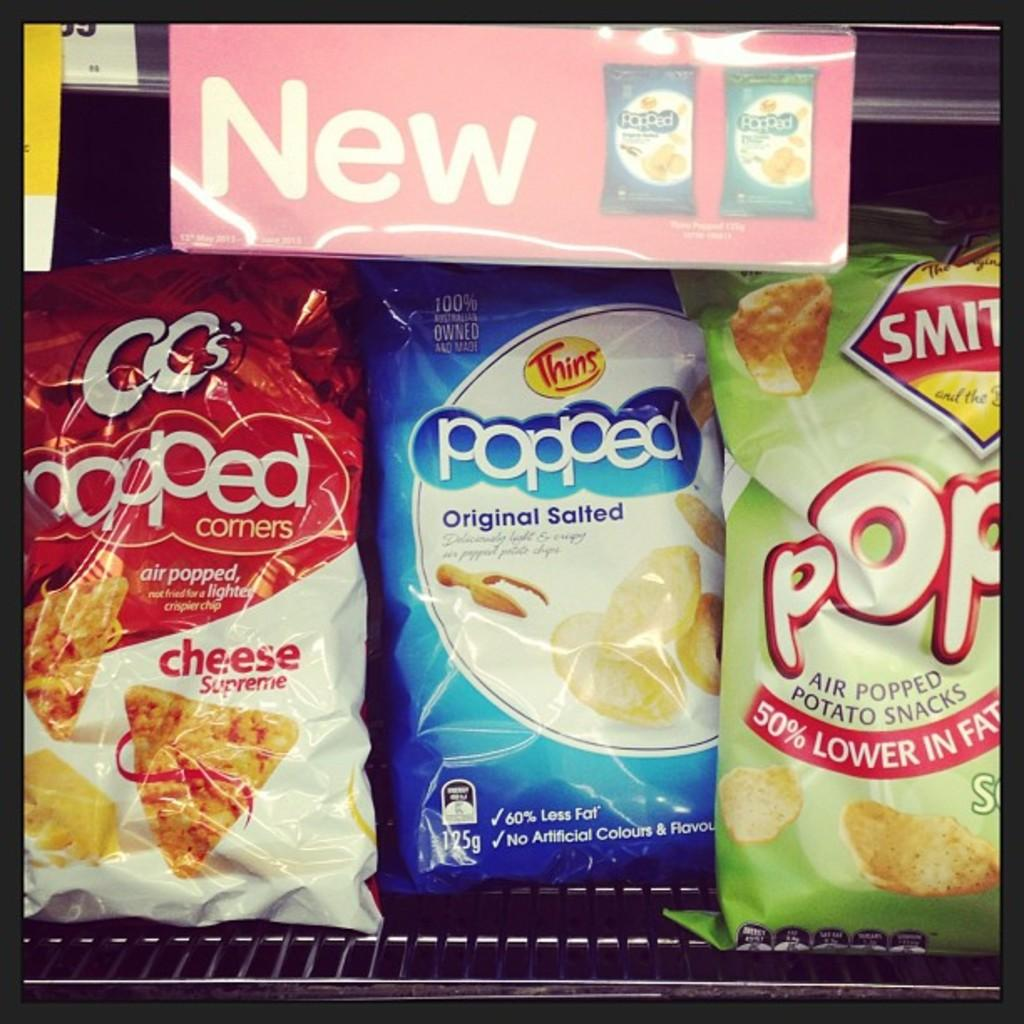What type of food items are present in the image? There are chips packets in the image. Where are the chips packets located? The chips packets are placed in a refrigerator. What type of toothbrush is visible in the image? There is no toothbrush present in the image. What mathematical operation can be performed on the chips packets in the image? There is no need to perform any mathematical operation on the chips packets in the image. 